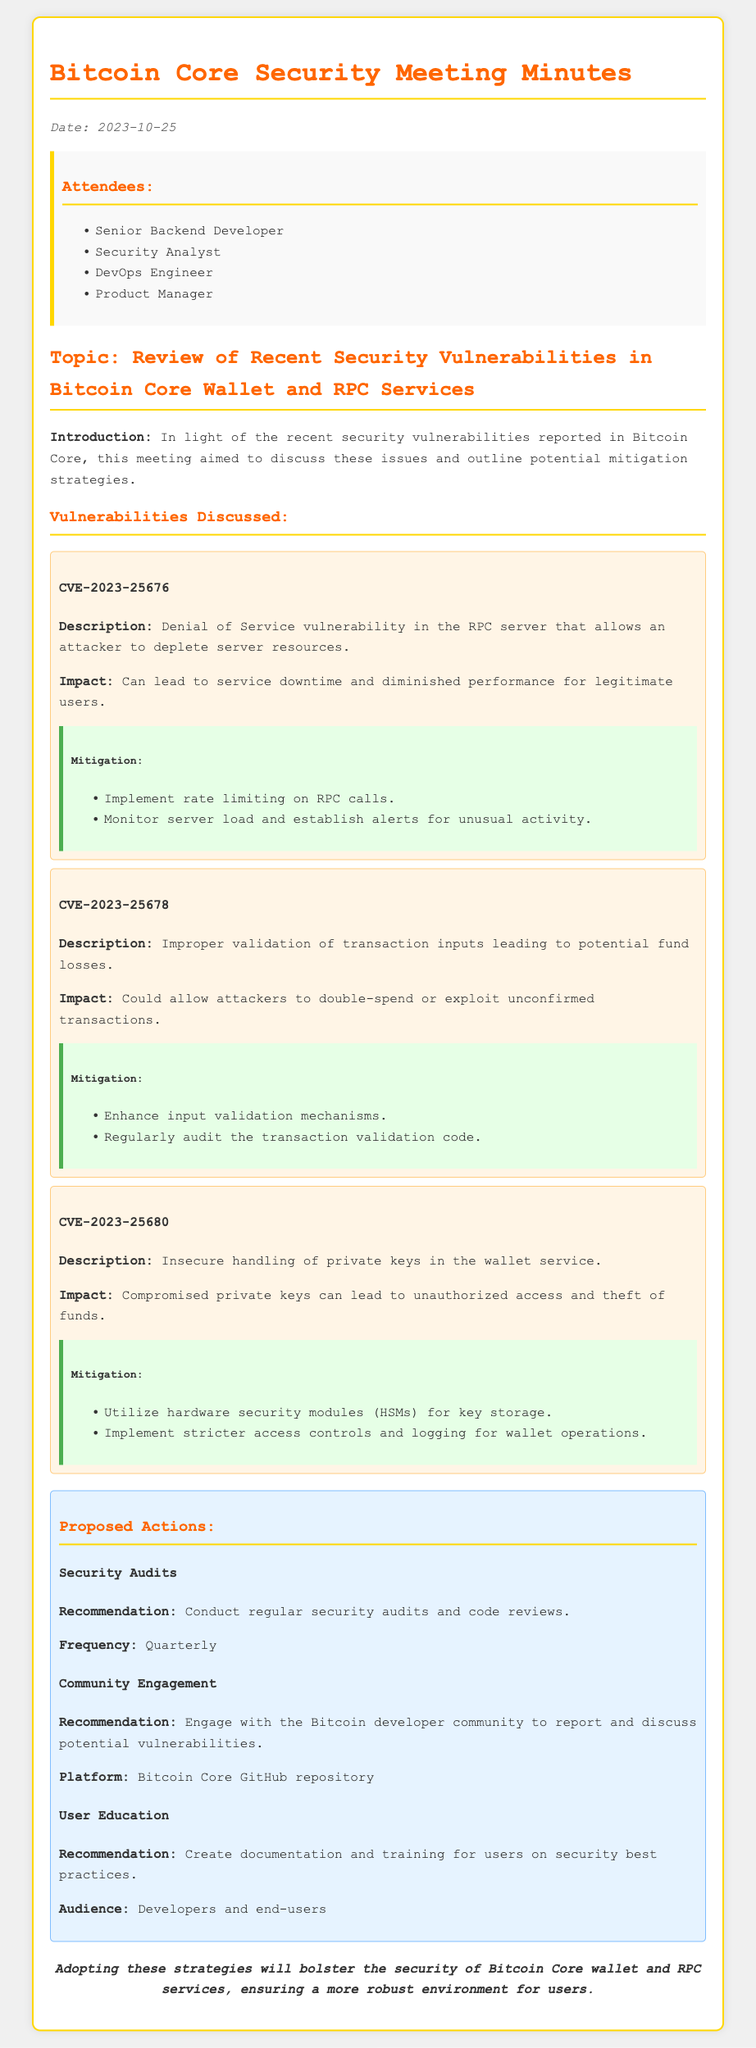What is the date of the meeting? The date of the meeting is mentioned at the beginning of the document as part of the introductory information.
Answer: 2023-10-25 What vulnerability is associated with CVE-2023-25676? This vulnerability is described under the "Vulnerabilities Discussed" section, specifically focusing on its details.
Answer: Denial of Service vulnerability What mitigation strategy is suggested for CVE-2023-25678? The mitigation strategy is provided in the "Mitigation" subsection of the vulnerability, detailing proposed actions to address it.
Answer: Enhance input validation mechanisms Who attended the meeting? The attendees are listed in the "Attendees" section, summarizing all individuals present during the meeting.
Answer: Senior Backend Developer, Security Analyst, DevOps Engineer, Product Manager What is the frequency for conducting security audits? The recommended frequency for security audits is specified in the "Proposed Actions" section.
Answer: Quarterly What does the conclusion emphasize regarding security? The conclusion offers a summary of the overall goals of the proposed strategies.
Answer: Bolster the security of Bitcoin Core wallet and RPC services 